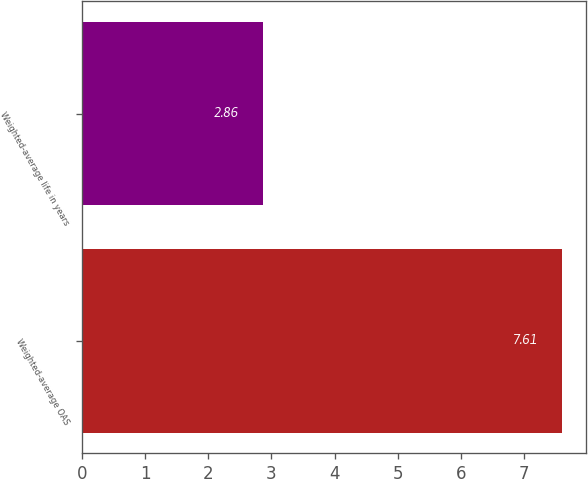Convert chart to OTSL. <chart><loc_0><loc_0><loc_500><loc_500><bar_chart><fcel>Weighted-average OAS<fcel>Weighted-average life in years<nl><fcel>7.61<fcel>2.86<nl></chart> 